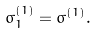<formula> <loc_0><loc_0><loc_500><loc_500>\sigma ^ { ( 1 ) } _ { 1 } = \sigma ^ { ( 1 ) } .</formula> 